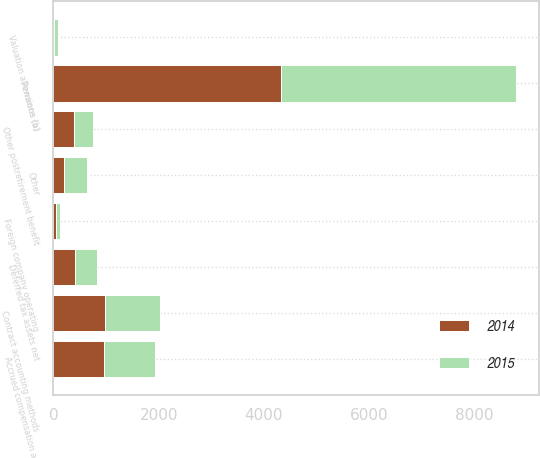Convert chart. <chart><loc_0><loc_0><loc_500><loc_500><stacked_bar_chart><ecel><fcel>Accrued compensation and<fcel>Pensions (a)<fcel>Other postretirement benefit<fcel>Contract accounting methods<fcel>Foreign company operating<fcel>Other<fcel>Valuation allowance (b)<fcel>Deferred tax assets net<nl><fcel>2015<fcel>961<fcel>4462<fcel>375<fcel>1039<fcel>70<fcel>434<fcel>76<fcel>410<nl><fcel>2014<fcel>965<fcel>4317<fcel>386<fcel>989<fcel>59<fcel>198<fcel>9<fcel>410<nl></chart> 